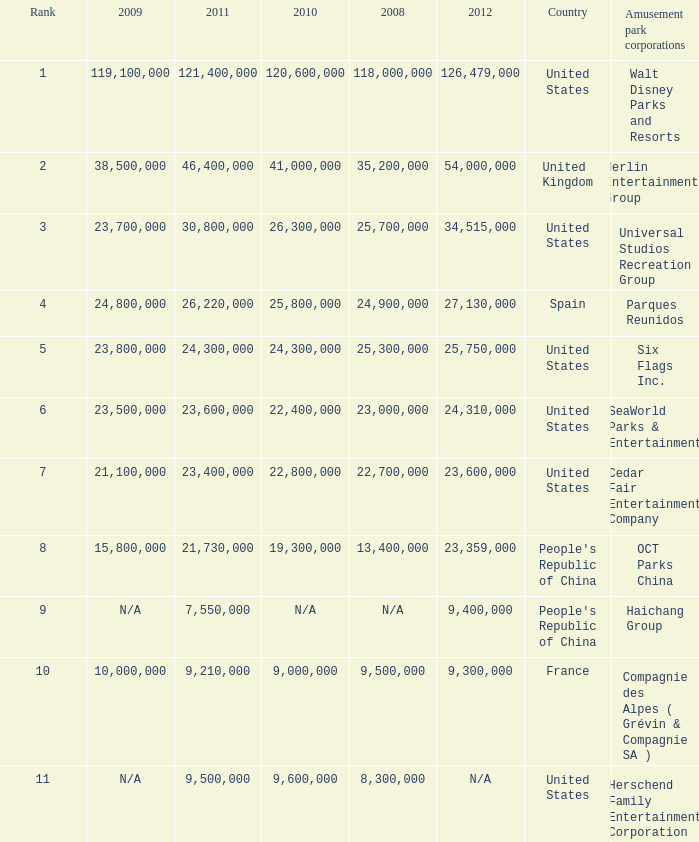In the United States the 2011 attendance at this amusement park corporation was larger than 30,800,000 but lists what as its 2008 attendance? 118000000.0. 